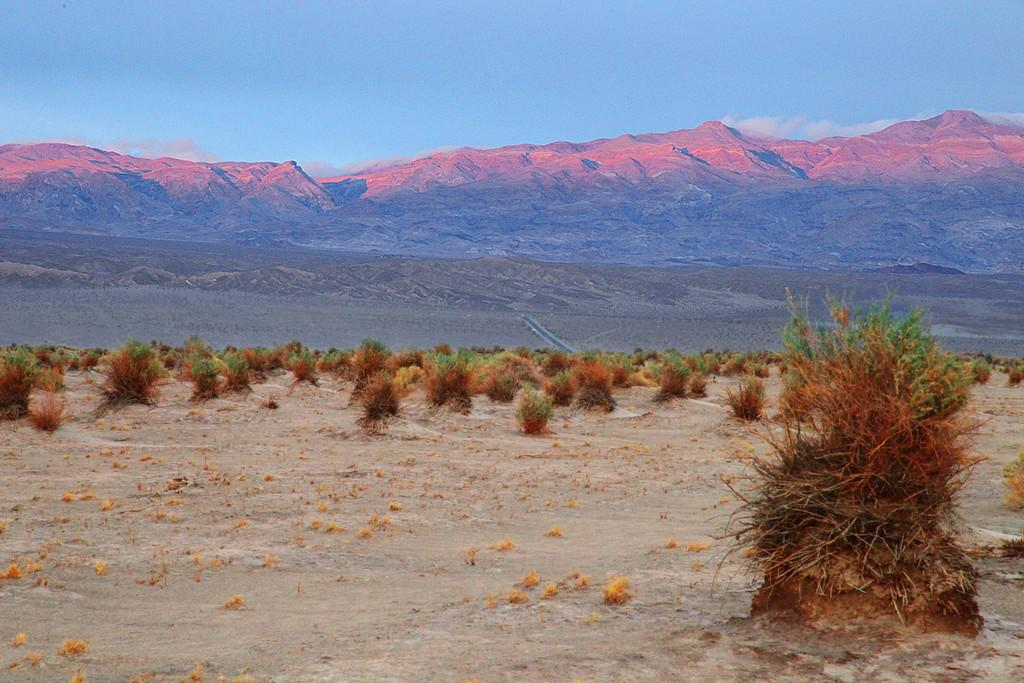What can be seen in the foreground of the image? There are shrubs and soil in the foreground of the image. What is located in the middle of the image? There are mountain ranges and a road in the middle of the image. What is visible at the top of the image? The sky is visible at the top of the image. What type of rod is used to measure the pollution in the image? There is no rod or mention of pollution present in the image. What color are the jeans worn by the person in the image? There is no person or jeans present in the image. 